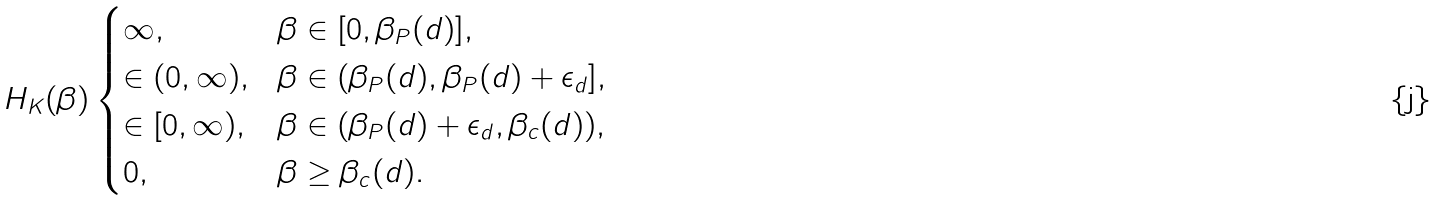Convert formula to latex. <formula><loc_0><loc_0><loc_500><loc_500>H _ { K } ( \beta ) \begin{cases} \infty , & \beta \in [ 0 , \beta _ { P } ( d ) ] , \\ \in ( 0 , \infty ) , & \beta \in ( \beta _ { P } ( d ) , \beta _ { P } ( d ) + \epsilon _ { d } ] , \\ \in [ 0 , \infty ) , & \beta \in ( \beta _ { P } ( d ) + \epsilon _ { d } , \beta _ { c } ( d ) ) , \\ 0 , & \beta \geq \beta _ { c } ( d ) . \end{cases}</formula> 